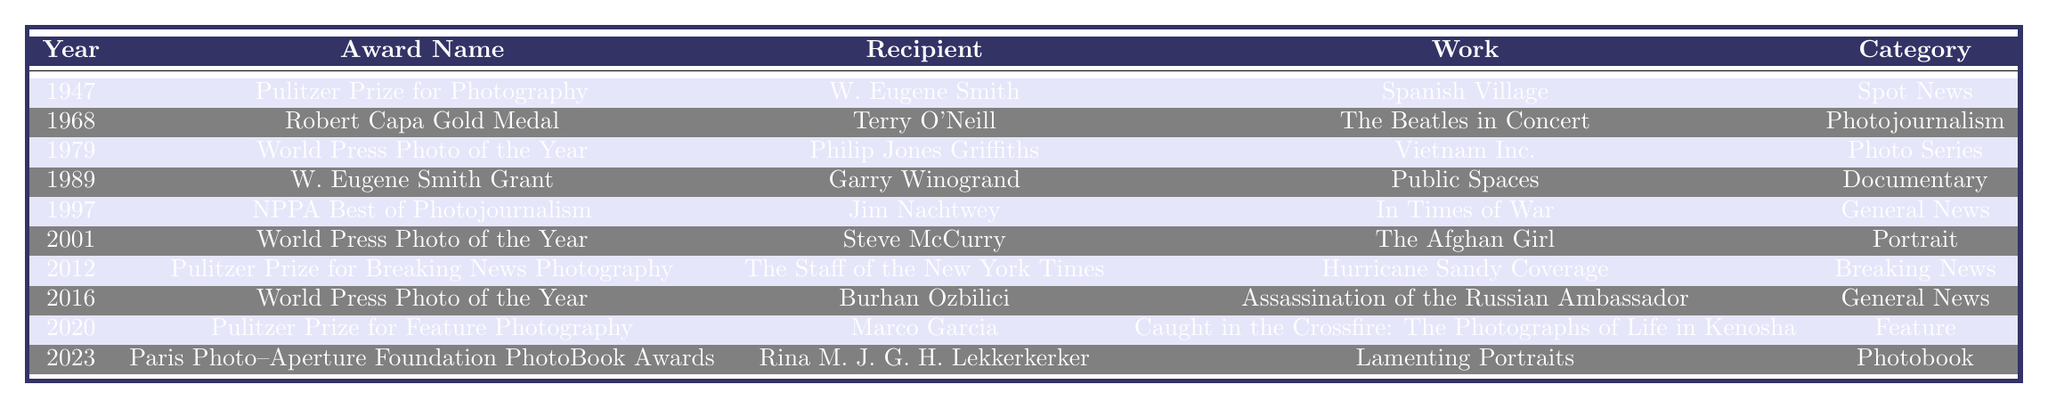What year did Terry O'Neill receive the Robert Capa Gold Medal? The table shows that Terry O'Neill was the recipient of the Robert Capa Gold Medal in the year 1968.
Answer: 1968 Who won the Pulitzer Prize for Feature Photography in 2020? The table indicates that Marco Garcia won the Pulitzer Prize for Feature Photography in the year 2020.
Answer: Marco Garcia How many different awards are listed in the table? There are 10 distinct awards mentioned in the table, each associated with various years and recipients.
Answer: 10 Which award was given for the work "The Afghan Girl"? By examining the table, it is clear that the World Press Photo of the Year award was given to Steve McCurry for the work "The Afghan Girl" in the year 2001.
Answer: World Press Photo of the Year Is W. Eugene Smith the recipient of more than one award listed in the table? The table shows that W. Eugene Smith is only mentioned once, as the recipient of the Pulitzer Prize for Photography in 1947, indicating that he did not receive more than one award in this list.
Answer: No What is the category of the work "Caught in the Crossfire: The Photographs of Life in Kenosha"? According to the table, the work "Caught in the Crossfire: The Photographs of Life in Kenosha" is categorized under Feature.
Answer: Feature Can you list the recipients of the World Press Photo of the Year award? The table shows that the recipients of the World Press Photo of the Year award are Philip Jones Griffiths (1979), Steve McCurry (2001), and Burhan Ozbilici (2016).
Answer: Philip Jones Griffiths, Steve McCurry, Burhan Ozbilici What is the earliest award listed in the table and its recipient? The earliest award in the table is the Pulitzer Prize for Photography, awarded to W. Eugene Smith in 1947.
Answer: Pulitzer Prize for Photography, W. Eugene Smith How many awards listed were given for general news? From the table, there are 2 awards categorized under General News: the NPPA Best of Photojournalism awarded to Jim Nachtwey in 1997 and the World Press Photo of the Year awarded to Burhan Ozbilici in 2016.
Answer: 2 Which recipient worked on a project involving Hurricane Sandy? The table identifies that the staff of the New York Times received the Pulitzer Prize for Breaking News Photography for their work on Hurricane Sandy Coverage in 2012.
Answer: The Staff of the New York Times 